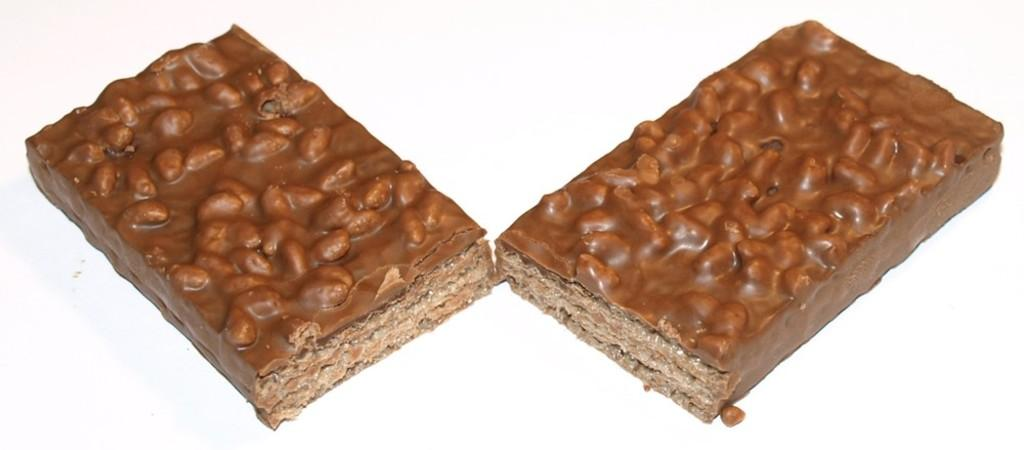What type of food items are present in the image? There are chocolate bars in the image. What color is the background of the image? The background of the image is white. What type of support can be seen in the image? There is no support present in the image. What material is the copper peace symbol made of in the image? There is no copper peace symbol present in the image. 